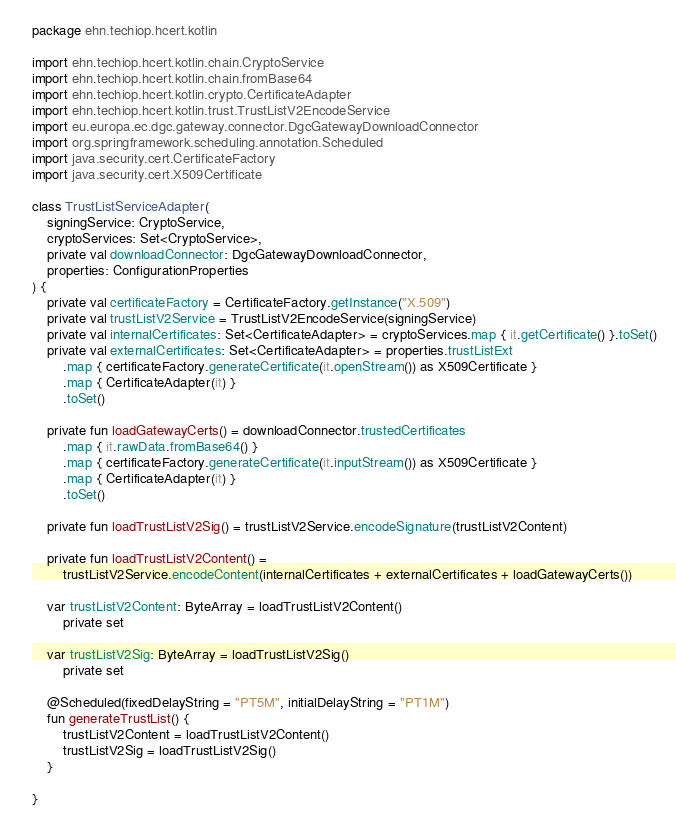Convert code to text. <code><loc_0><loc_0><loc_500><loc_500><_Kotlin_>package ehn.techiop.hcert.kotlin

import ehn.techiop.hcert.kotlin.chain.CryptoService
import ehn.techiop.hcert.kotlin.chain.fromBase64
import ehn.techiop.hcert.kotlin.crypto.CertificateAdapter
import ehn.techiop.hcert.kotlin.trust.TrustListV2EncodeService
import eu.europa.ec.dgc.gateway.connector.DgcGatewayDownloadConnector
import org.springframework.scheduling.annotation.Scheduled
import java.security.cert.CertificateFactory
import java.security.cert.X509Certificate

class TrustListServiceAdapter(
    signingService: CryptoService,
    cryptoServices: Set<CryptoService>,
    private val downloadConnector: DgcGatewayDownloadConnector,
    properties: ConfigurationProperties
) {
    private val certificateFactory = CertificateFactory.getInstance("X.509")
    private val trustListV2Service = TrustListV2EncodeService(signingService)
    private val internalCertificates: Set<CertificateAdapter> = cryptoServices.map { it.getCertificate() }.toSet()
    private val externalCertificates: Set<CertificateAdapter> = properties.trustListExt
        .map { certificateFactory.generateCertificate(it.openStream()) as X509Certificate }
        .map { CertificateAdapter(it) }
        .toSet()

    private fun loadGatewayCerts() = downloadConnector.trustedCertificates
        .map { it.rawData.fromBase64() }
        .map { certificateFactory.generateCertificate(it.inputStream()) as X509Certificate }
        .map { CertificateAdapter(it) }
        .toSet()

    private fun loadTrustListV2Sig() = trustListV2Service.encodeSignature(trustListV2Content)

    private fun loadTrustListV2Content() =
        trustListV2Service.encodeContent(internalCertificates + externalCertificates + loadGatewayCerts())

    var trustListV2Content: ByteArray = loadTrustListV2Content()
        private set

    var trustListV2Sig: ByteArray = loadTrustListV2Sig()
        private set

    @Scheduled(fixedDelayString = "PT5M", initialDelayString = "PT1M")
    fun generateTrustList() {
        trustListV2Content = loadTrustListV2Content()
        trustListV2Sig = loadTrustListV2Sig()
    }

}</code> 